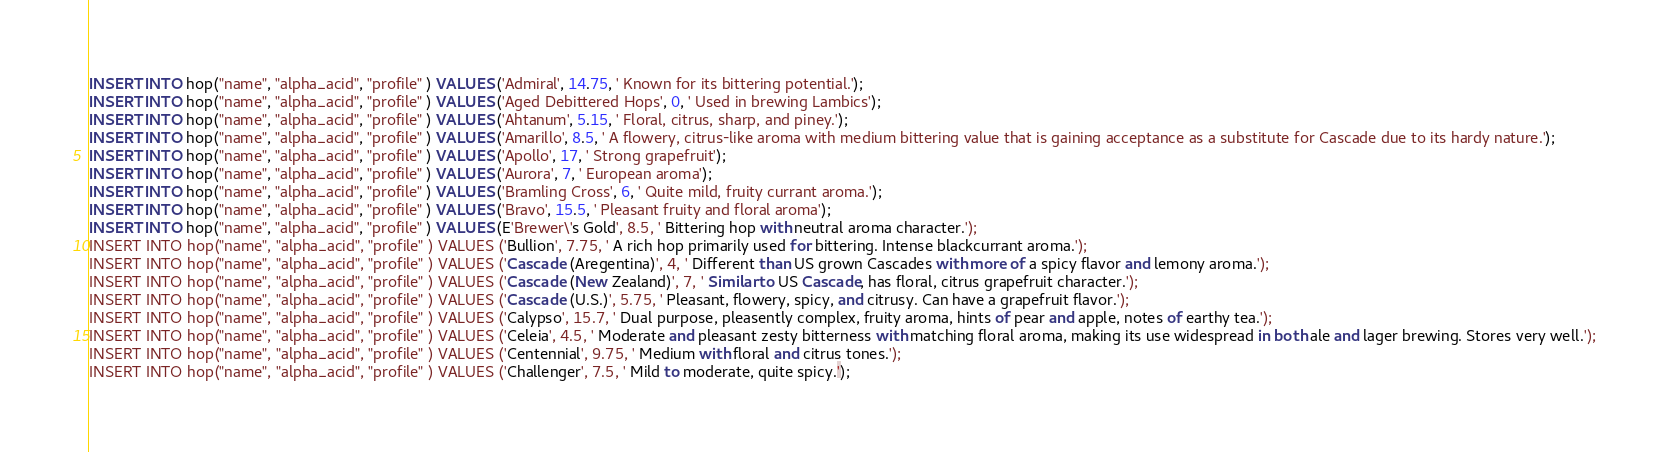<code> <loc_0><loc_0><loc_500><loc_500><_SQL_>INSERT INTO hop("name", "alpha_acid", "profile" ) VALUES ('Admiral', 14.75, ' Known for its bittering potential.');
INSERT INTO hop("name", "alpha_acid", "profile" ) VALUES ('Aged Debittered Hops', 0, ' Used in brewing Lambics');
INSERT INTO hop("name", "alpha_acid", "profile" ) VALUES ('Ahtanum', 5.15, ' Floral, citrus, sharp, and piney.');
INSERT INTO hop("name", "alpha_acid", "profile" ) VALUES ('Amarillo', 8.5, ' A flowery, citrus-like aroma with medium bittering value that is gaining acceptance as a substitute for Cascade due to its hardy nature.');
INSERT INTO hop("name", "alpha_acid", "profile" ) VALUES ('Apollo', 17, ' Strong grapefruit');
INSERT INTO hop("name", "alpha_acid", "profile" ) VALUES ('Aurora', 7, ' European aroma');
INSERT INTO hop("name", "alpha_acid", "profile" ) VALUES ('Bramling Cross', 6, ' Quite mild, fruity currant aroma.');
INSERT INTO hop("name", "alpha_acid", "profile" ) VALUES ('Bravo', 15.5, ' Pleasant fruity and floral aroma');
INSERT INTO hop("name", "alpha_acid", "profile" ) VALUES (E'Brewer\'s Gold', 8.5, ' Bittering hop with neutral aroma character.');
INSERT INTO hop("name", "alpha_acid", "profile" ) VALUES ('Bullion', 7.75, ' A rich hop primarily used for bittering. Intense blackcurrant aroma.');
INSERT INTO hop("name", "alpha_acid", "profile" ) VALUES ('Cascade (Aregentina)', 4, ' Different than US grown Cascades with more of a spicy flavor and lemony aroma.');
INSERT INTO hop("name", "alpha_acid", "profile" ) VALUES ('Cascade (New Zealand)', 7, ' Similar to US Cascade, has floral, citrus grapefruit character.');
INSERT INTO hop("name", "alpha_acid", "profile" ) VALUES ('Cascade (U.S.)', 5.75, ' Pleasant, flowery, spicy, and citrusy. Can have a grapefruit flavor.');
INSERT INTO hop("name", "alpha_acid", "profile" ) VALUES ('Calypso', 15.7, ' Dual purpose, pleasently complex, fruity aroma, hints of pear and apple, notes of earthy tea.');
INSERT INTO hop("name", "alpha_acid", "profile" ) VALUES ('Celeia', 4.5, ' Moderate and pleasant zesty bitterness with matching floral aroma, making its use widespread in both ale and lager brewing. Stores very well.');
INSERT INTO hop("name", "alpha_acid", "profile" ) VALUES ('Centennial', 9.75, ' Medium with floral and citrus tones.');
INSERT INTO hop("name", "alpha_acid", "profile" ) VALUES ('Challenger', 7.5, ' Mild to moderate, quite spicy.');</code> 